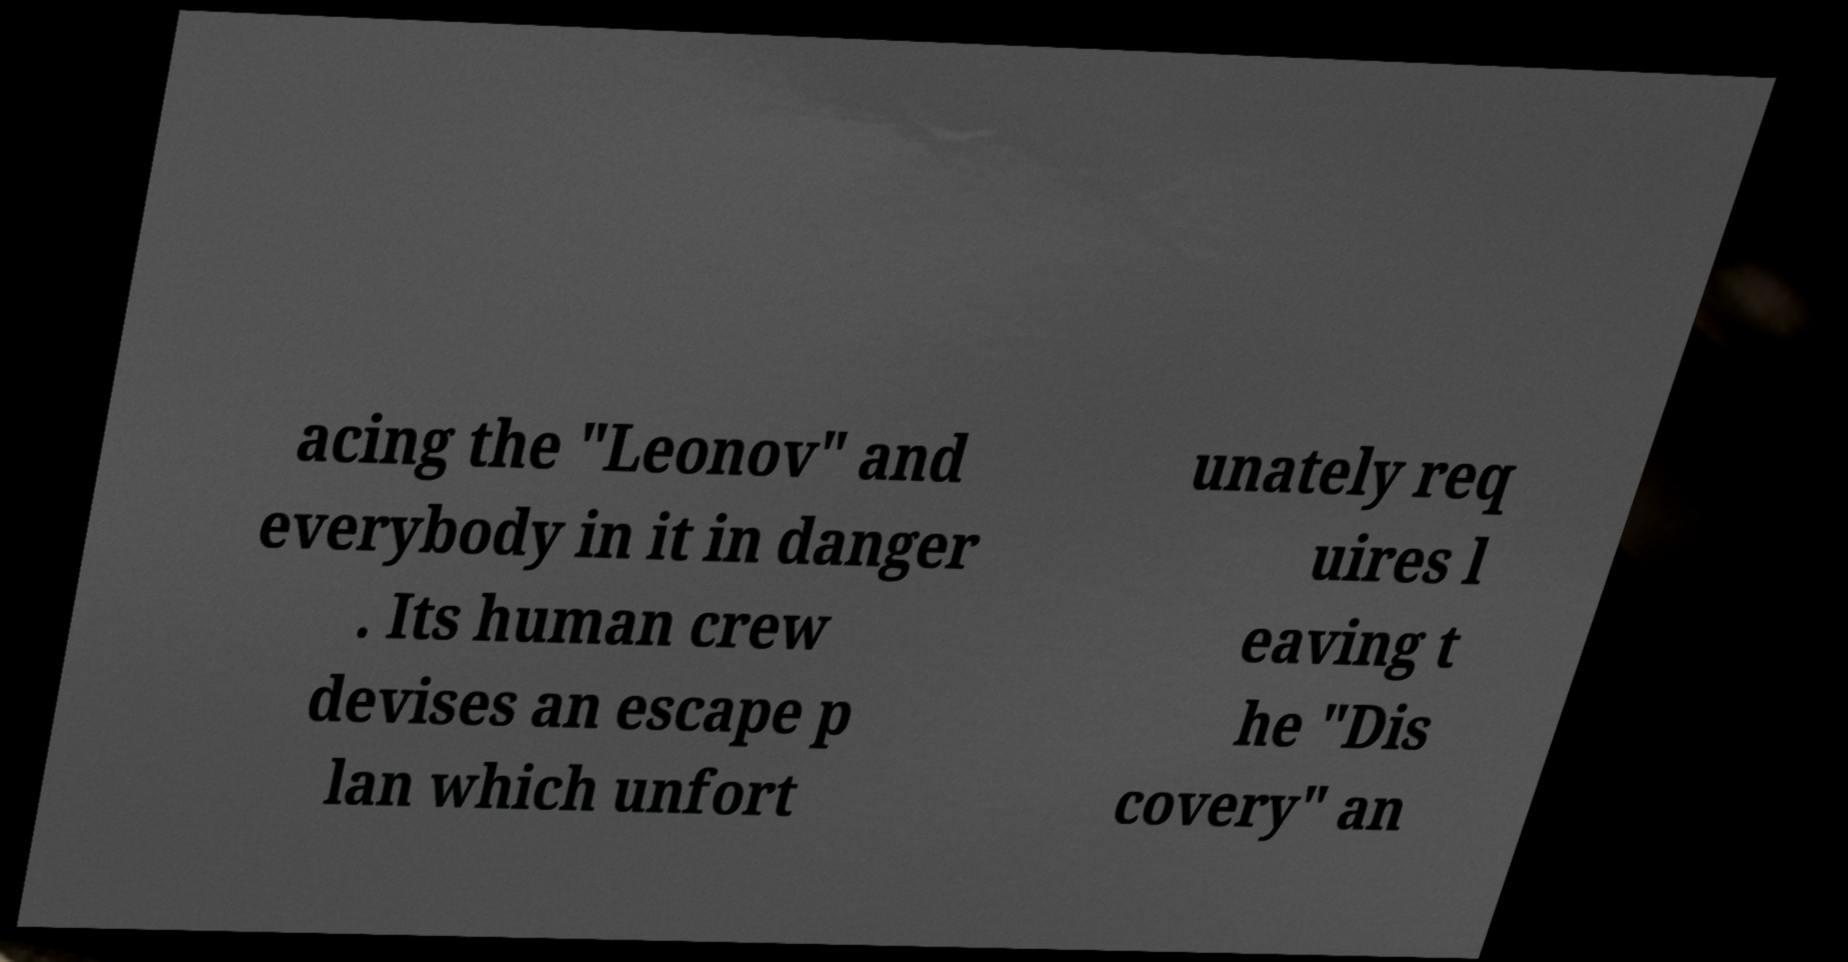For documentation purposes, I need the text within this image transcribed. Could you provide that? acing the "Leonov" and everybody in it in danger . Its human crew devises an escape p lan which unfort unately req uires l eaving t he "Dis covery" an 